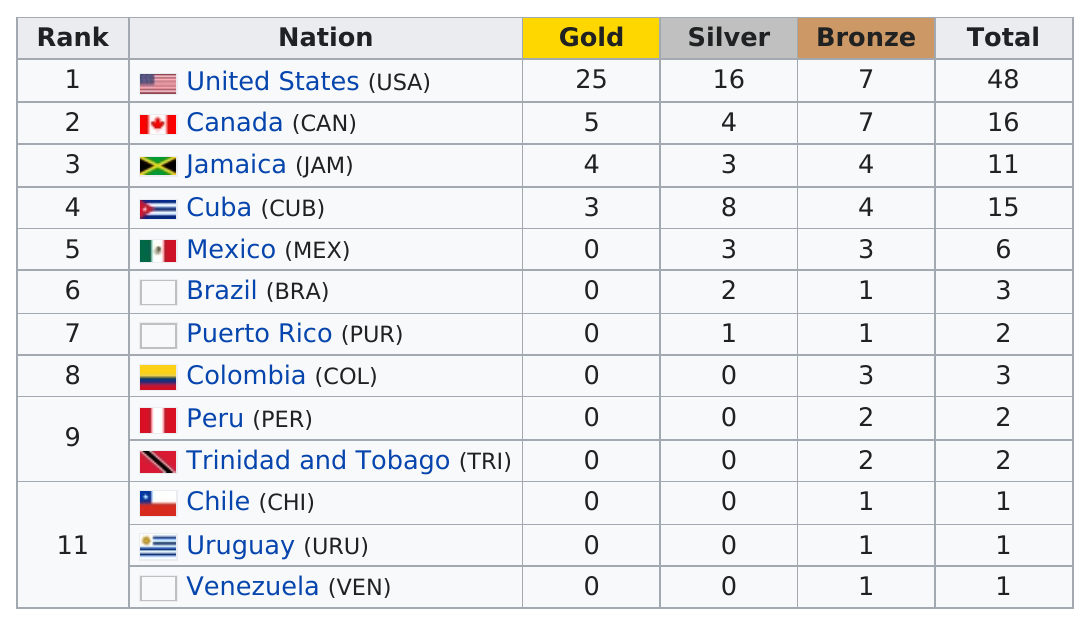Point out several critical features in this image. Puerto Rico did not earn any gold medals at the games. Venezuela came in last place. Chile, Uruguay, and Venezuela are tied for last place. The total number of bronze medals awarded is 37. Out of the total number of nations participating, only 6 did not win a silver medal. 